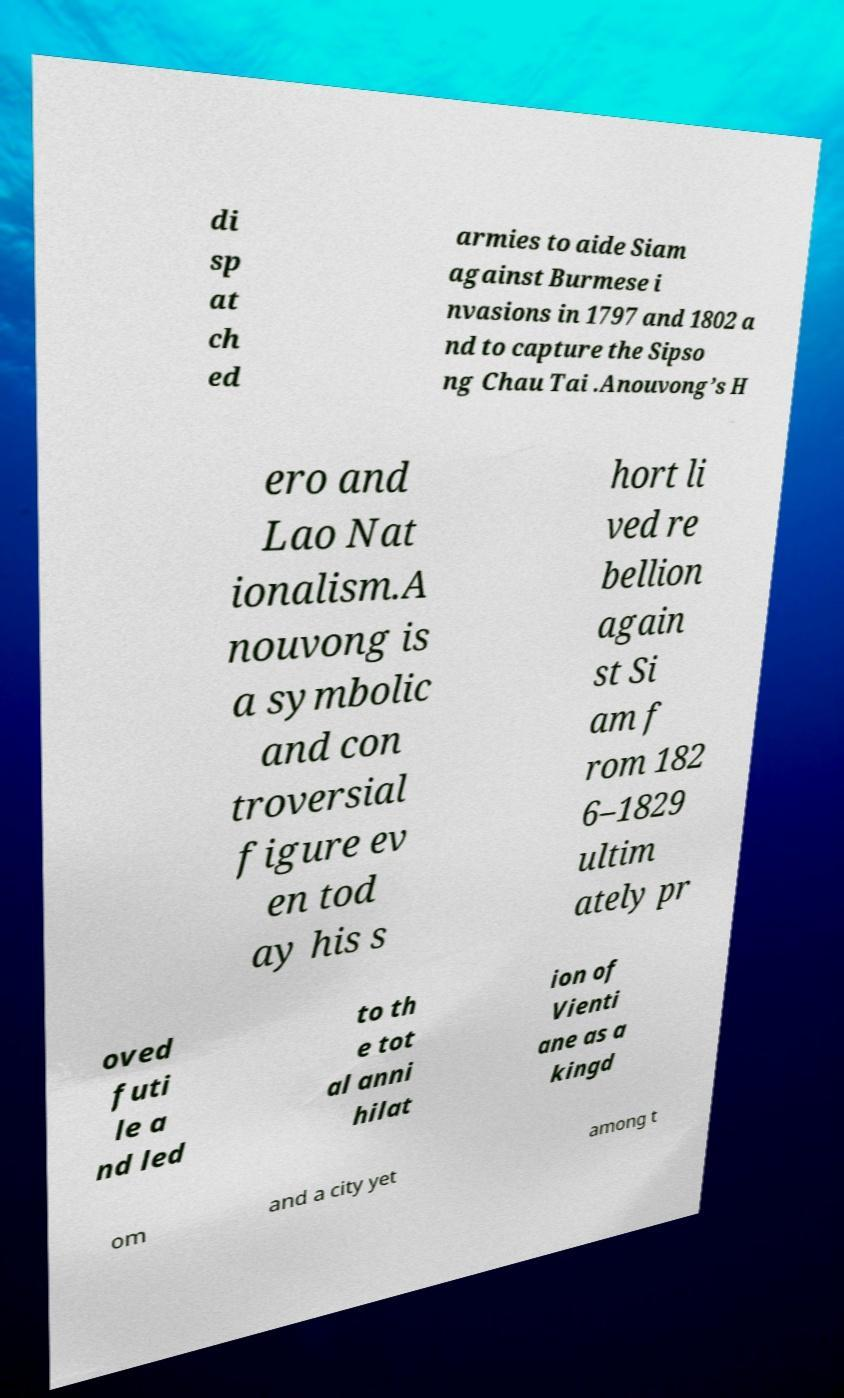Can you read and provide the text displayed in the image?This photo seems to have some interesting text. Can you extract and type it out for me? di sp at ch ed armies to aide Siam against Burmese i nvasions in 1797 and 1802 a nd to capture the Sipso ng Chau Tai .Anouvong’s H ero and Lao Nat ionalism.A nouvong is a symbolic and con troversial figure ev en tod ay his s hort li ved re bellion again st Si am f rom 182 6–1829 ultim ately pr oved futi le a nd led to th e tot al anni hilat ion of Vienti ane as a kingd om and a city yet among t 